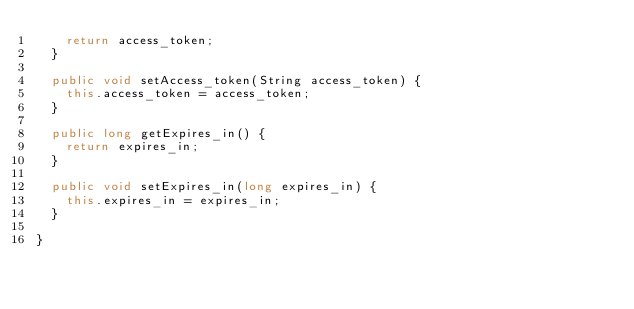<code> <loc_0><loc_0><loc_500><loc_500><_Java_>		return access_token;
	}

	public void setAccess_token(String access_token) {
		this.access_token = access_token;
	}

	public long getExpires_in() {
		return expires_in;
	}

	public void setExpires_in(long expires_in) {
		this.expires_in = expires_in;
	}
	
}
</code> 